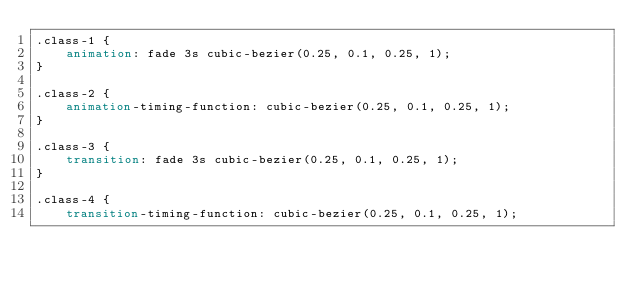<code> <loc_0><loc_0><loc_500><loc_500><_CSS_>.class-1 {
    animation: fade 3s cubic-bezier(0.25, 0.1, 0.25, 1);
}

.class-2 {
    animation-timing-function: cubic-bezier(0.25, 0.1, 0.25, 1);
}

.class-3 {
    transition: fade 3s cubic-bezier(0.25, 0.1, 0.25, 1);
}

.class-4 {
    transition-timing-function: cubic-bezier(0.25, 0.1, 0.25, 1);</code> 